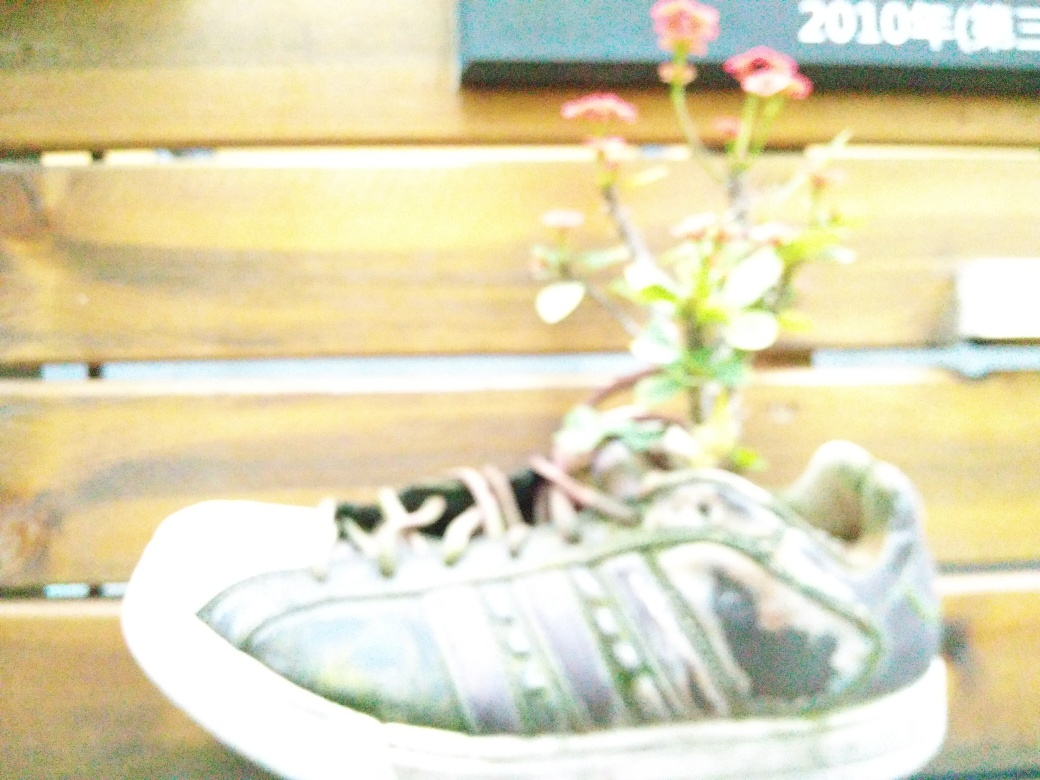Does the photo depict a pot of a plant shaped like shoes?
A. No
B. Yes
Answer with the option's letter from the given choices directly.
 B. 